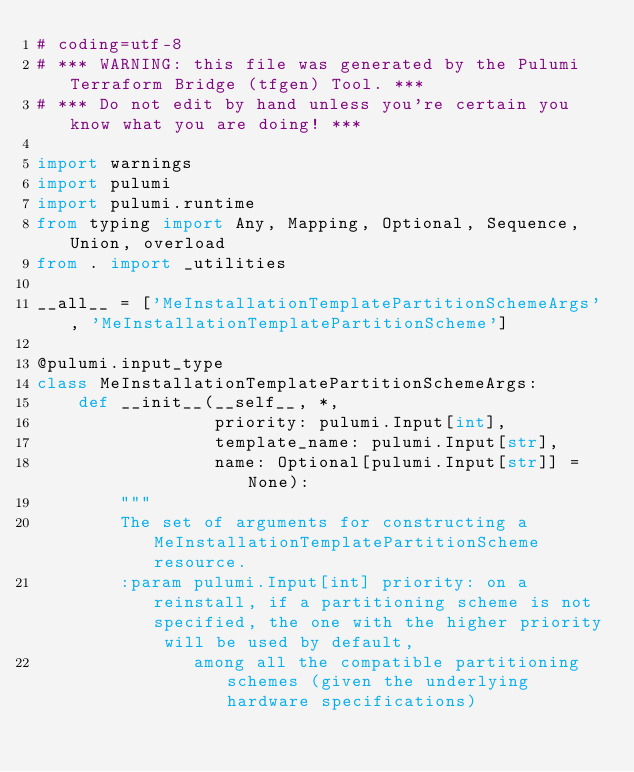Convert code to text. <code><loc_0><loc_0><loc_500><loc_500><_Python_># coding=utf-8
# *** WARNING: this file was generated by the Pulumi Terraform Bridge (tfgen) Tool. ***
# *** Do not edit by hand unless you're certain you know what you are doing! ***

import warnings
import pulumi
import pulumi.runtime
from typing import Any, Mapping, Optional, Sequence, Union, overload
from . import _utilities

__all__ = ['MeInstallationTemplatePartitionSchemeArgs', 'MeInstallationTemplatePartitionScheme']

@pulumi.input_type
class MeInstallationTemplatePartitionSchemeArgs:
    def __init__(__self__, *,
                 priority: pulumi.Input[int],
                 template_name: pulumi.Input[str],
                 name: Optional[pulumi.Input[str]] = None):
        """
        The set of arguments for constructing a MeInstallationTemplatePartitionScheme resource.
        :param pulumi.Input[int] priority: on a reinstall, if a partitioning scheme is not specified, the one with the higher priority will be used by default,
               among all the compatible partitioning schemes (given the underlying hardware specifications)</code> 